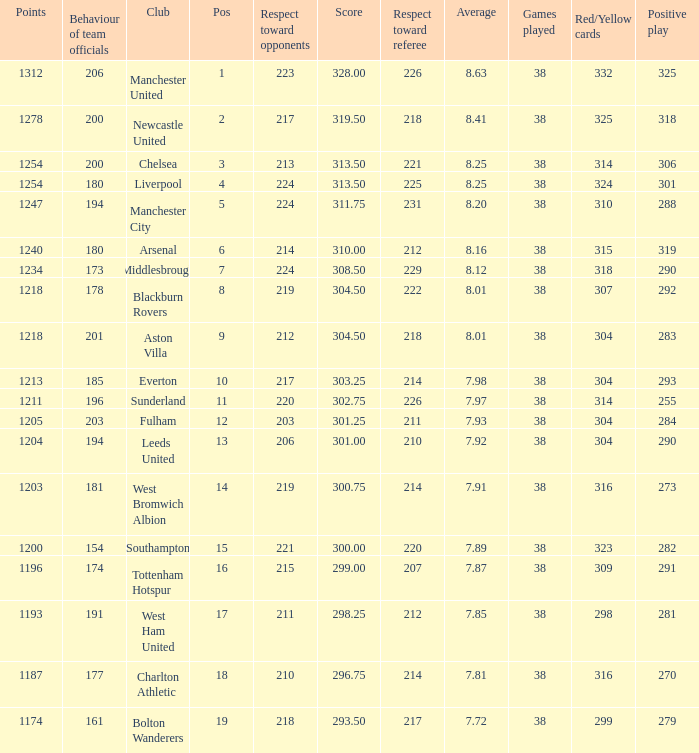Name the most pos for west bromwich albion club 14.0. Help me parse the entirety of this table. {'header': ['Points', 'Behaviour of team officials', 'Club', 'Pos', 'Respect toward opponents', 'Score', 'Respect toward referee', 'Average', 'Games played', 'Red/Yellow cards', 'Positive play'], 'rows': [['1312', '206', 'Manchester United', '1', '223', '328.00', '226', '8.63', '38', '332', '325'], ['1278', '200', 'Newcastle United', '2', '217', '319.50', '218', '8.41', '38', '325', '318'], ['1254', '200', 'Chelsea', '3', '213', '313.50', '221', '8.25', '38', '314', '306'], ['1254', '180', 'Liverpool', '4', '224', '313.50', '225', '8.25', '38', '324', '301'], ['1247', '194', 'Manchester City', '5', '224', '311.75', '231', '8.20', '38', '310', '288'], ['1240', '180', 'Arsenal', '6', '214', '310.00', '212', '8.16', '38', '315', '319'], ['1234', '173', 'Middlesbrough', '7', '224', '308.50', '229', '8.12', '38', '318', '290'], ['1218', '178', 'Blackburn Rovers', '8', '219', '304.50', '222', '8.01', '38', '307', '292'], ['1218', '201', 'Aston Villa', '9', '212', '304.50', '218', '8.01', '38', '304', '283'], ['1213', '185', 'Everton', '10', '217', '303.25', '214', '7.98', '38', '304', '293'], ['1211', '196', 'Sunderland', '11', '220', '302.75', '226', '7.97', '38', '314', '255'], ['1205', '203', 'Fulham', '12', '203', '301.25', '211', '7.93', '38', '304', '284'], ['1204', '194', 'Leeds United', '13', '206', '301.00', '210', '7.92', '38', '304', '290'], ['1203', '181', 'West Bromwich Albion', '14', '219', '300.75', '214', '7.91', '38', '316', '273'], ['1200', '154', 'Southampton', '15', '221', '300.00', '220', '7.89', '38', '323', '282'], ['1196', '174', 'Tottenham Hotspur', '16', '215', '299.00', '207', '7.87', '38', '309', '291'], ['1193', '191', 'West Ham United', '17', '211', '298.25', '212', '7.85', '38', '298', '281'], ['1187', '177', 'Charlton Athletic', '18', '210', '296.75', '214', '7.81', '38', '316', '270'], ['1174', '161', 'Bolton Wanderers', '19', '218', '293.50', '217', '7.72', '38', '299', '279']]} 